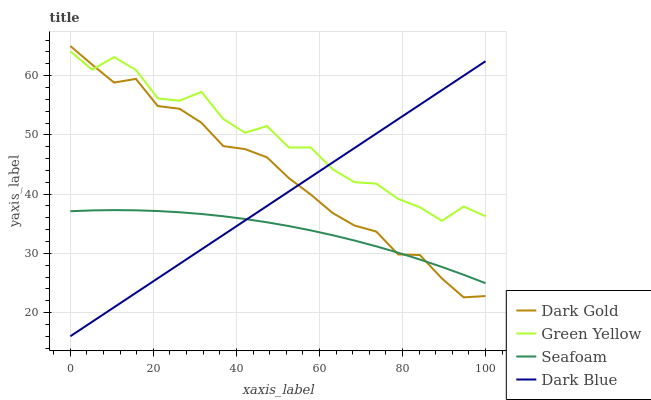Does Seafoam have the minimum area under the curve?
Answer yes or no. Yes. Does Green Yellow have the maximum area under the curve?
Answer yes or no. Yes. Does Green Yellow have the minimum area under the curve?
Answer yes or no. No. Does Seafoam have the maximum area under the curve?
Answer yes or no. No. Is Dark Blue the smoothest?
Answer yes or no. Yes. Is Green Yellow the roughest?
Answer yes or no. Yes. Is Seafoam the smoothest?
Answer yes or no. No. Is Seafoam the roughest?
Answer yes or no. No. Does Dark Blue have the lowest value?
Answer yes or no. Yes. Does Seafoam have the lowest value?
Answer yes or no. No. Does Dark Gold have the highest value?
Answer yes or no. Yes. Does Green Yellow have the highest value?
Answer yes or no. No. Is Seafoam less than Green Yellow?
Answer yes or no. Yes. Is Green Yellow greater than Seafoam?
Answer yes or no. Yes. Does Dark Blue intersect Seafoam?
Answer yes or no. Yes. Is Dark Blue less than Seafoam?
Answer yes or no. No. Is Dark Blue greater than Seafoam?
Answer yes or no. No. Does Seafoam intersect Green Yellow?
Answer yes or no. No. 